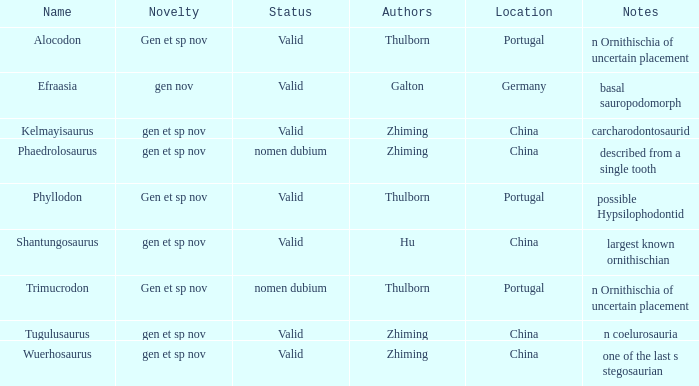What is the originality of the dinosaur designated by the creator, zhiming, and whose annotations are, "carcharodontosaurid"? Gen et sp nov. 